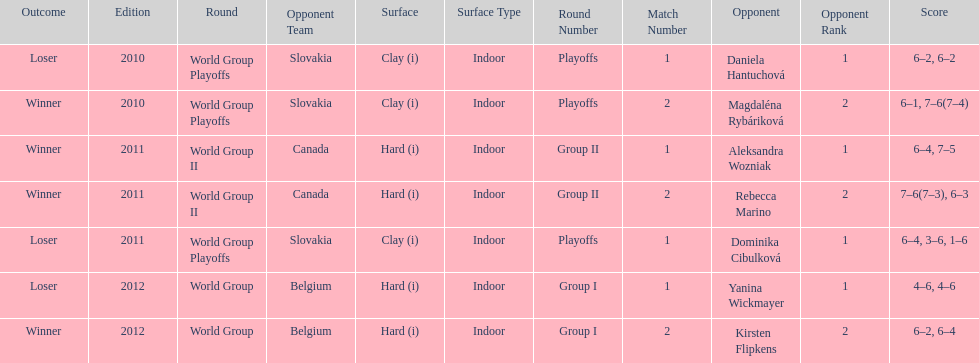Did they beat canada in more or less than 3 matches? Less. 